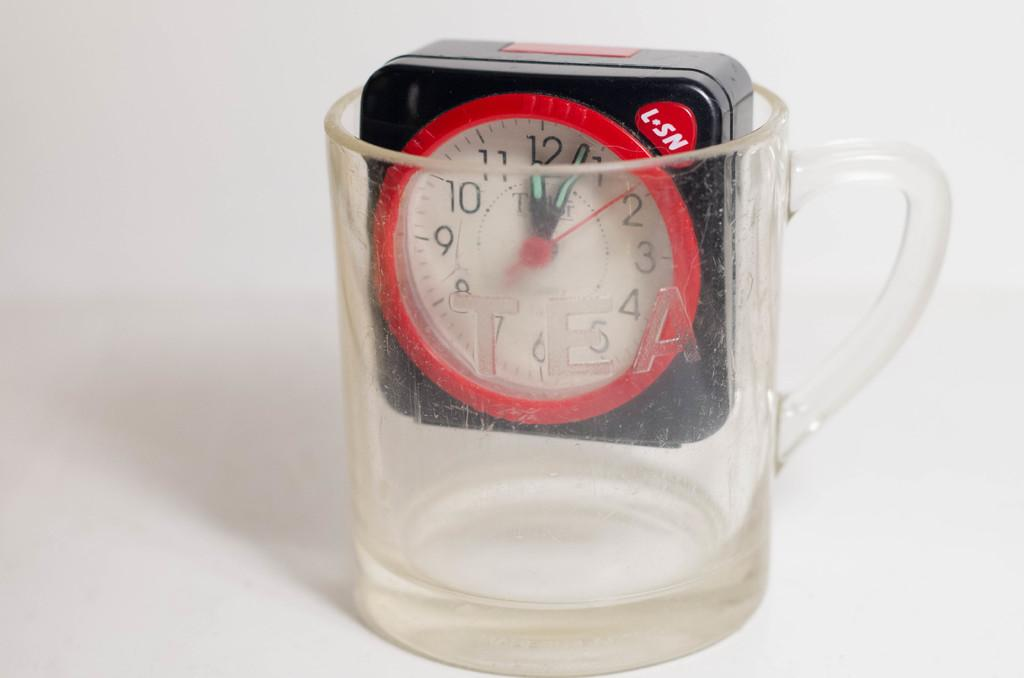<image>
Share a concise interpretation of the image provided. L-SN clock places inside an empty glass cup. 